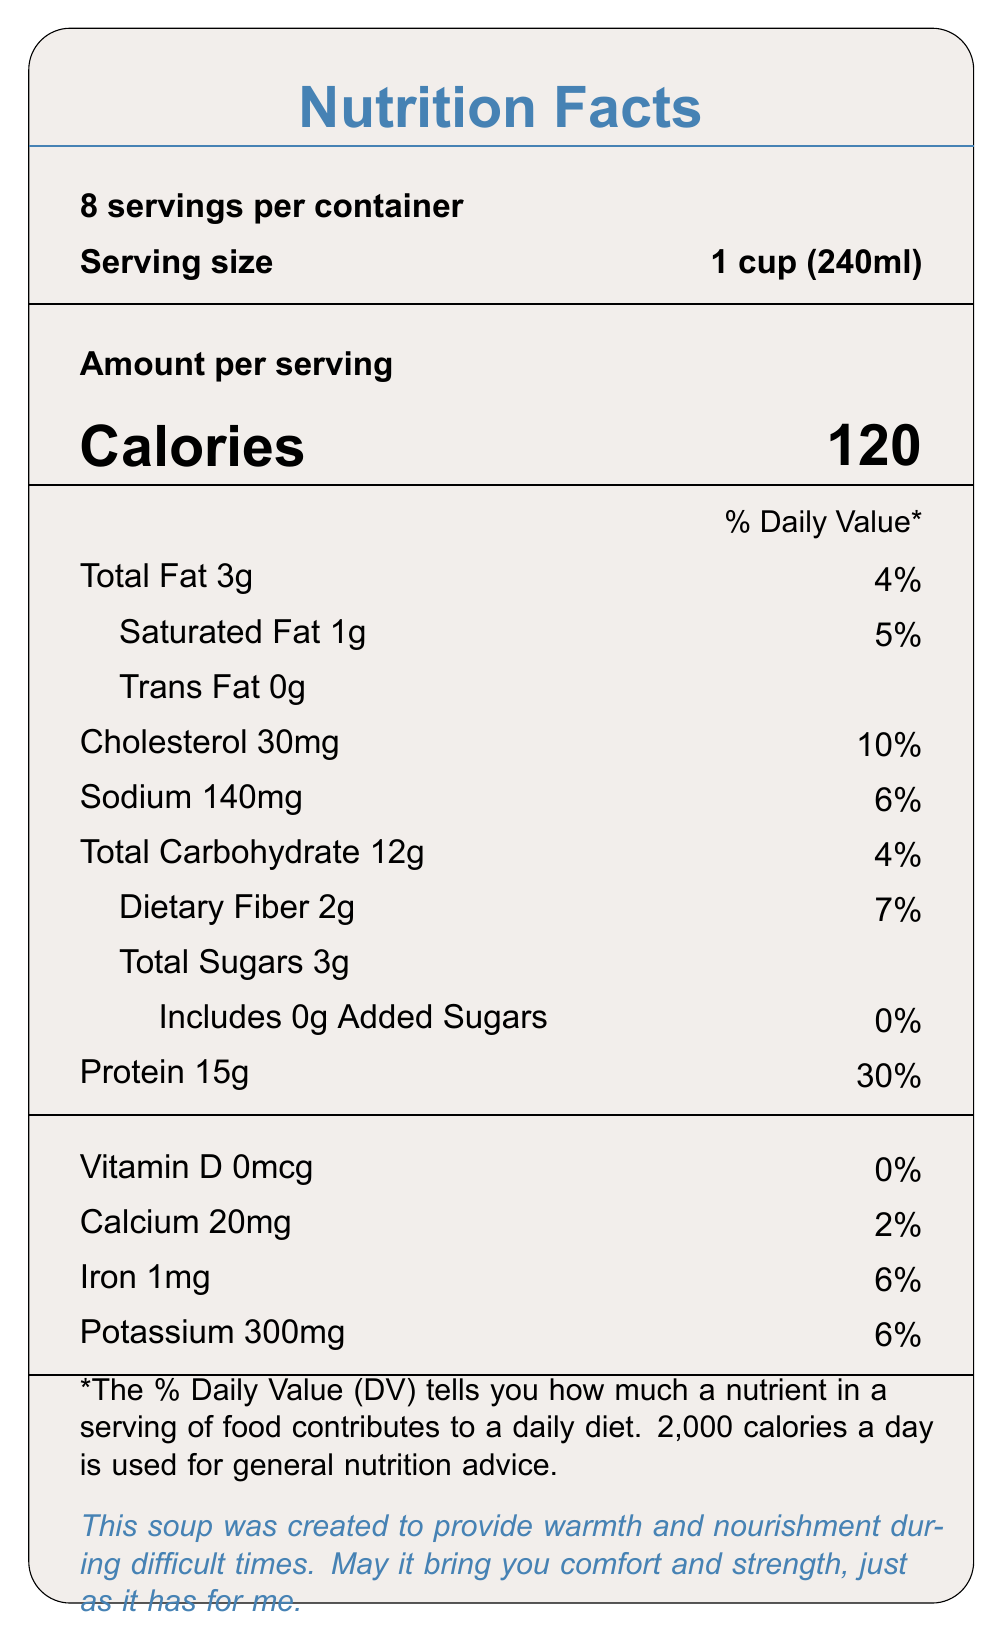what is the serving size? The serving size is clearly stated at the top of the nutrition facts as "Serving size: 1 cup (240ml)."
Answer: 1 cup (240ml) how many servings are in the container? The document specifies "8 servings per container" right below the title "Nutrition Facts."
Answer: 8 how many calories are in one serving? The number of calories per serving is prominently displayed as "Calories: 120."
Answer: 120 what is the percentage of daily value for protein? The protein amount and its daily value percentage are listed as "Protein 15g" followed by "30%."
Answer: 30% what is the amount of sodium per serving? The sodium amount per serving is listed as "Sodium 140mg."
Answer: 140mg which ingredient provides the primary source of protein? Organic chicken breast is the first ingredient listed, which is typically the predominant ingredient and a common source of protein.
Answer: Organic chicken breast does this soup contain any allergens? The document lists "Allergens: None," indicating that there are no known allergens in the soup.
Answer: No how much dietary fiber is in each serving? The dietary fiber amount is listed as "Dietary Fiber 2g."
Answer: 2g what is the main message conveyed in the comforting message section? The document includes a touching message at the bottom, stating "This soup was created to provide warmth and nourishment during difficult times."
Answer: This soup was created to provide warmth and nourishment during difficult times. how much cholesterol is in one serving? The cholesterol amount per serving is listed as "Cholesterol 30mg."
Answer: 30mg what portion of the daily value of calcium does one serving provide? A. 6% B. 2% C. 20% The document states "Calcium 20mg" which equates to "2%" of the daily value.
Answer: B what is the percentage of daily value of iron provided by one serving? A. 6% B. 2% C. 10% D. 7% The document states "Iron 1mg" which equates to "6%" of the daily value.
Answer: A is vitamin D present in the soup? The vitamin D amount is listed as "Vitamin D 0mcg" with a daily value of "0%," indicating it is not present.
Answer: No write a summary of the document The summary captures the main points of the Nutrition Facts label, highlighting key nutritional values, ingredients, the comforting message, and the soup’s purpose.
Answer: The document presents the Nutrition Facts for a comforting homemade chicken soup. It includes serving size (1 cup), servings per container (8), calories per serving (120), and detailed amounts for fats, cholesterol, sodium, carbohydrates, protein, and various vitamins and minerals. Ingredients include organic chicken breast and a variety of vegetables, and there are no allergens. A comforting message is included, highlighting the soup's purpose to provide warmth and nourishment. The document also contains preparation tips and special notes about its low sodium and high protein content. is the total sugar content high in this soup? The document lists "Total Sugars 3g," which is relatively low for one serving.
Answer: No what preparation tip is suggested for adding extra flavor? One of the preparation tips listed is "Add fresh herbs before serving for extra flavor."
Answer: Add fresh herbs before serving. what are the main benefits of this soup according to the document? The special notes section highlights these main benefits: "Low sodium recipe to support heart health" and "High in protein to promote healing and strength."
Answer: Low sodium to support heart health and high in protein to promote healing and strength. what is the ingredient used for cooking fat? Among the ingredients listed, olive oil is commonly used as a cooking fat.
Answer: Olive oil what is not clearly indicated about the sodium content in this soup? While the document mentions low-sodium chicken broth, it does not specify the brand or specific sodium content of the broth itself.
Answer: Specific source of low-sodium chicken broth 